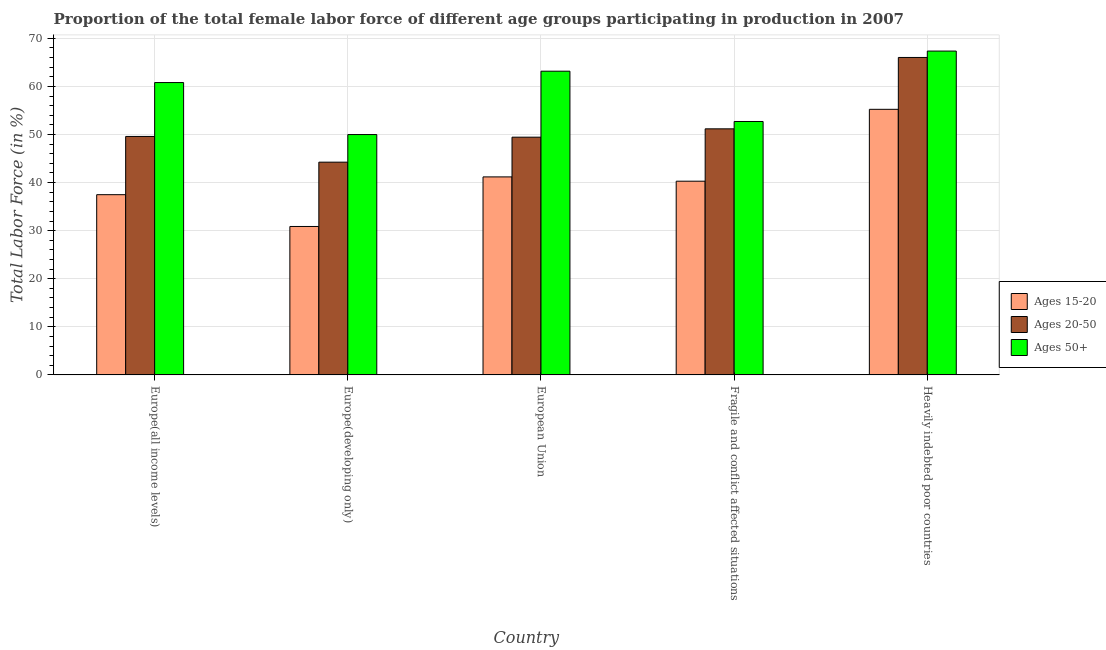How many different coloured bars are there?
Your response must be concise. 3. Are the number of bars on each tick of the X-axis equal?
Your response must be concise. Yes. How many bars are there on the 2nd tick from the left?
Your answer should be compact. 3. What is the label of the 2nd group of bars from the left?
Offer a very short reply. Europe(developing only). In how many cases, is the number of bars for a given country not equal to the number of legend labels?
Your answer should be compact. 0. What is the percentage of female labor force above age 50 in Europe(developing only)?
Make the answer very short. 49.99. Across all countries, what is the maximum percentage of female labor force above age 50?
Offer a terse response. 67.36. Across all countries, what is the minimum percentage of female labor force above age 50?
Make the answer very short. 49.99. In which country was the percentage of female labor force above age 50 maximum?
Your answer should be very brief. Heavily indebted poor countries. In which country was the percentage of female labor force within the age group 15-20 minimum?
Ensure brevity in your answer.  Europe(developing only). What is the total percentage of female labor force within the age group 20-50 in the graph?
Keep it short and to the point. 260.52. What is the difference between the percentage of female labor force above age 50 in Europe(all income levels) and that in Heavily indebted poor countries?
Your answer should be compact. -6.55. What is the difference between the percentage of female labor force within the age group 15-20 in Heavily indebted poor countries and the percentage of female labor force above age 50 in Europe(developing only)?
Your answer should be very brief. 5.25. What is the average percentage of female labor force above age 50 per country?
Provide a short and direct response. 58.81. What is the difference between the percentage of female labor force within the age group 15-20 and percentage of female labor force within the age group 20-50 in Heavily indebted poor countries?
Keep it short and to the point. -10.79. What is the ratio of the percentage of female labor force within the age group 15-20 in Europe(all income levels) to that in European Union?
Provide a succinct answer. 0.91. Is the difference between the percentage of female labor force above age 50 in Europe(developing only) and Heavily indebted poor countries greater than the difference between the percentage of female labor force within the age group 15-20 in Europe(developing only) and Heavily indebted poor countries?
Provide a short and direct response. Yes. What is the difference between the highest and the second highest percentage of female labor force within the age group 20-50?
Make the answer very short. 14.85. What is the difference between the highest and the lowest percentage of female labor force within the age group 20-50?
Provide a succinct answer. 21.78. In how many countries, is the percentage of female labor force above age 50 greater than the average percentage of female labor force above age 50 taken over all countries?
Make the answer very short. 3. Is the sum of the percentage of female labor force within the age group 15-20 in Europe(developing only) and Heavily indebted poor countries greater than the maximum percentage of female labor force above age 50 across all countries?
Provide a short and direct response. Yes. What does the 2nd bar from the left in European Union represents?
Give a very brief answer. Ages 20-50. What does the 1st bar from the right in Europe(all income levels) represents?
Offer a terse response. Ages 50+. Are all the bars in the graph horizontal?
Make the answer very short. No. What is the difference between two consecutive major ticks on the Y-axis?
Provide a short and direct response. 10. Does the graph contain any zero values?
Your response must be concise. No. Where does the legend appear in the graph?
Ensure brevity in your answer.  Center right. How many legend labels are there?
Ensure brevity in your answer.  3. What is the title of the graph?
Provide a short and direct response. Proportion of the total female labor force of different age groups participating in production in 2007. Does "Unemployment benefits" appear as one of the legend labels in the graph?
Provide a succinct answer. No. What is the Total Labor Force (in %) in Ages 15-20 in Europe(all income levels)?
Your answer should be very brief. 37.49. What is the Total Labor Force (in %) in Ages 20-50 in Europe(all income levels)?
Your answer should be compact. 49.6. What is the Total Labor Force (in %) in Ages 50+ in Europe(all income levels)?
Give a very brief answer. 60.81. What is the Total Labor Force (in %) in Ages 15-20 in Europe(developing only)?
Give a very brief answer. 30.88. What is the Total Labor Force (in %) in Ages 20-50 in Europe(developing only)?
Make the answer very short. 44.25. What is the Total Labor Force (in %) of Ages 50+ in Europe(developing only)?
Your response must be concise. 49.99. What is the Total Labor Force (in %) in Ages 15-20 in European Union?
Offer a very short reply. 41.19. What is the Total Labor Force (in %) in Ages 20-50 in European Union?
Keep it short and to the point. 49.45. What is the Total Labor Force (in %) of Ages 50+ in European Union?
Offer a very short reply. 63.17. What is the Total Labor Force (in %) in Ages 15-20 in Fragile and conflict affected situations?
Your answer should be compact. 40.29. What is the Total Labor Force (in %) in Ages 20-50 in Fragile and conflict affected situations?
Your answer should be compact. 51.19. What is the Total Labor Force (in %) in Ages 50+ in Fragile and conflict affected situations?
Ensure brevity in your answer.  52.71. What is the Total Labor Force (in %) of Ages 15-20 in Heavily indebted poor countries?
Ensure brevity in your answer.  55.25. What is the Total Labor Force (in %) of Ages 20-50 in Heavily indebted poor countries?
Offer a very short reply. 66.03. What is the Total Labor Force (in %) in Ages 50+ in Heavily indebted poor countries?
Make the answer very short. 67.36. Across all countries, what is the maximum Total Labor Force (in %) of Ages 15-20?
Make the answer very short. 55.25. Across all countries, what is the maximum Total Labor Force (in %) in Ages 20-50?
Provide a succinct answer. 66.03. Across all countries, what is the maximum Total Labor Force (in %) of Ages 50+?
Make the answer very short. 67.36. Across all countries, what is the minimum Total Labor Force (in %) of Ages 15-20?
Give a very brief answer. 30.88. Across all countries, what is the minimum Total Labor Force (in %) of Ages 20-50?
Give a very brief answer. 44.25. Across all countries, what is the minimum Total Labor Force (in %) in Ages 50+?
Make the answer very short. 49.99. What is the total Total Labor Force (in %) in Ages 15-20 in the graph?
Keep it short and to the point. 205.09. What is the total Total Labor Force (in %) of Ages 20-50 in the graph?
Provide a succinct answer. 260.52. What is the total Total Labor Force (in %) of Ages 50+ in the graph?
Make the answer very short. 294.05. What is the difference between the Total Labor Force (in %) in Ages 15-20 in Europe(all income levels) and that in Europe(developing only)?
Give a very brief answer. 6.61. What is the difference between the Total Labor Force (in %) of Ages 20-50 in Europe(all income levels) and that in Europe(developing only)?
Offer a terse response. 5.35. What is the difference between the Total Labor Force (in %) of Ages 50+ in Europe(all income levels) and that in Europe(developing only)?
Your answer should be very brief. 10.82. What is the difference between the Total Labor Force (in %) of Ages 15-20 in Europe(all income levels) and that in European Union?
Make the answer very short. -3.7. What is the difference between the Total Labor Force (in %) of Ages 20-50 in Europe(all income levels) and that in European Union?
Your response must be concise. 0.15. What is the difference between the Total Labor Force (in %) of Ages 50+ in Europe(all income levels) and that in European Union?
Keep it short and to the point. -2.36. What is the difference between the Total Labor Force (in %) in Ages 15-20 in Europe(all income levels) and that in Fragile and conflict affected situations?
Keep it short and to the point. -2.81. What is the difference between the Total Labor Force (in %) of Ages 20-50 in Europe(all income levels) and that in Fragile and conflict affected situations?
Provide a short and direct response. -1.58. What is the difference between the Total Labor Force (in %) in Ages 50+ in Europe(all income levels) and that in Fragile and conflict affected situations?
Your answer should be compact. 8.1. What is the difference between the Total Labor Force (in %) in Ages 15-20 in Europe(all income levels) and that in Heavily indebted poor countries?
Offer a terse response. -17.76. What is the difference between the Total Labor Force (in %) of Ages 20-50 in Europe(all income levels) and that in Heavily indebted poor countries?
Offer a very short reply. -16.43. What is the difference between the Total Labor Force (in %) in Ages 50+ in Europe(all income levels) and that in Heavily indebted poor countries?
Your response must be concise. -6.55. What is the difference between the Total Labor Force (in %) of Ages 15-20 in Europe(developing only) and that in European Union?
Provide a succinct answer. -10.31. What is the difference between the Total Labor Force (in %) of Ages 20-50 in Europe(developing only) and that in European Union?
Offer a very short reply. -5.2. What is the difference between the Total Labor Force (in %) of Ages 50+ in Europe(developing only) and that in European Union?
Make the answer very short. -13.18. What is the difference between the Total Labor Force (in %) in Ages 15-20 in Europe(developing only) and that in Fragile and conflict affected situations?
Offer a very short reply. -9.42. What is the difference between the Total Labor Force (in %) of Ages 20-50 in Europe(developing only) and that in Fragile and conflict affected situations?
Offer a terse response. -6.93. What is the difference between the Total Labor Force (in %) in Ages 50+ in Europe(developing only) and that in Fragile and conflict affected situations?
Provide a short and direct response. -2.72. What is the difference between the Total Labor Force (in %) in Ages 15-20 in Europe(developing only) and that in Heavily indebted poor countries?
Provide a short and direct response. -24.37. What is the difference between the Total Labor Force (in %) of Ages 20-50 in Europe(developing only) and that in Heavily indebted poor countries?
Your answer should be very brief. -21.78. What is the difference between the Total Labor Force (in %) of Ages 50+ in Europe(developing only) and that in Heavily indebted poor countries?
Your answer should be compact. -17.37. What is the difference between the Total Labor Force (in %) of Ages 15-20 in European Union and that in Fragile and conflict affected situations?
Ensure brevity in your answer.  0.89. What is the difference between the Total Labor Force (in %) in Ages 20-50 in European Union and that in Fragile and conflict affected situations?
Offer a terse response. -1.73. What is the difference between the Total Labor Force (in %) in Ages 50+ in European Union and that in Fragile and conflict affected situations?
Make the answer very short. 10.46. What is the difference between the Total Labor Force (in %) of Ages 15-20 in European Union and that in Heavily indebted poor countries?
Offer a very short reply. -14.06. What is the difference between the Total Labor Force (in %) in Ages 20-50 in European Union and that in Heavily indebted poor countries?
Offer a terse response. -16.58. What is the difference between the Total Labor Force (in %) of Ages 50+ in European Union and that in Heavily indebted poor countries?
Your answer should be compact. -4.19. What is the difference between the Total Labor Force (in %) in Ages 15-20 in Fragile and conflict affected situations and that in Heavily indebted poor countries?
Provide a short and direct response. -14.95. What is the difference between the Total Labor Force (in %) of Ages 20-50 in Fragile and conflict affected situations and that in Heavily indebted poor countries?
Offer a very short reply. -14.85. What is the difference between the Total Labor Force (in %) in Ages 50+ in Fragile and conflict affected situations and that in Heavily indebted poor countries?
Offer a terse response. -14.65. What is the difference between the Total Labor Force (in %) in Ages 15-20 in Europe(all income levels) and the Total Labor Force (in %) in Ages 20-50 in Europe(developing only)?
Give a very brief answer. -6.76. What is the difference between the Total Labor Force (in %) in Ages 15-20 in Europe(all income levels) and the Total Labor Force (in %) in Ages 50+ in Europe(developing only)?
Your answer should be very brief. -12.51. What is the difference between the Total Labor Force (in %) in Ages 20-50 in Europe(all income levels) and the Total Labor Force (in %) in Ages 50+ in Europe(developing only)?
Your answer should be compact. -0.39. What is the difference between the Total Labor Force (in %) in Ages 15-20 in Europe(all income levels) and the Total Labor Force (in %) in Ages 20-50 in European Union?
Make the answer very short. -11.96. What is the difference between the Total Labor Force (in %) in Ages 15-20 in Europe(all income levels) and the Total Labor Force (in %) in Ages 50+ in European Union?
Provide a short and direct response. -25.69. What is the difference between the Total Labor Force (in %) in Ages 20-50 in Europe(all income levels) and the Total Labor Force (in %) in Ages 50+ in European Union?
Keep it short and to the point. -13.57. What is the difference between the Total Labor Force (in %) in Ages 15-20 in Europe(all income levels) and the Total Labor Force (in %) in Ages 20-50 in Fragile and conflict affected situations?
Your answer should be compact. -13.7. What is the difference between the Total Labor Force (in %) of Ages 15-20 in Europe(all income levels) and the Total Labor Force (in %) of Ages 50+ in Fragile and conflict affected situations?
Offer a terse response. -15.23. What is the difference between the Total Labor Force (in %) in Ages 20-50 in Europe(all income levels) and the Total Labor Force (in %) in Ages 50+ in Fragile and conflict affected situations?
Offer a terse response. -3.11. What is the difference between the Total Labor Force (in %) in Ages 15-20 in Europe(all income levels) and the Total Labor Force (in %) in Ages 20-50 in Heavily indebted poor countries?
Provide a short and direct response. -28.54. What is the difference between the Total Labor Force (in %) in Ages 15-20 in Europe(all income levels) and the Total Labor Force (in %) in Ages 50+ in Heavily indebted poor countries?
Ensure brevity in your answer.  -29.87. What is the difference between the Total Labor Force (in %) in Ages 20-50 in Europe(all income levels) and the Total Labor Force (in %) in Ages 50+ in Heavily indebted poor countries?
Offer a very short reply. -17.76. What is the difference between the Total Labor Force (in %) in Ages 15-20 in Europe(developing only) and the Total Labor Force (in %) in Ages 20-50 in European Union?
Offer a very short reply. -18.57. What is the difference between the Total Labor Force (in %) in Ages 15-20 in Europe(developing only) and the Total Labor Force (in %) in Ages 50+ in European Union?
Provide a succinct answer. -32.3. What is the difference between the Total Labor Force (in %) of Ages 20-50 in Europe(developing only) and the Total Labor Force (in %) of Ages 50+ in European Union?
Provide a succinct answer. -18.92. What is the difference between the Total Labor Force (in %) in Ages 15-20 in Europe(developing only) and the Total Labor Force (in %) in Ages 20-50 in Fragile and conflict affected situations?
Keep it short and to the point. -20.31. What is the difference between the Total Labor Force (in %) of Ages 15-20 in Europe(developing only) and the Total Labor Force (in %) of Ages 50+ in Fragile and conflict affected situations?
Ensure brevity in your answer.  -21.84. What is the difference between the Total Labor Force (in %) in Ages 20-50 in Europe(developing only) and the Total Labor Force (in %) in Ages 50+ in Fragile and conflict affected situations?
Provide a succinct answer. -8.46. What is the difference between the Total Labor Force (in %) of Ages 15-20 in Europe(developing only) and the Total Labor Force (in %) of Ages 20-50 in Heavily indebted poor countries?
Ensure brevity in your answer.  -35.15. What is the difference between the Total Labor Force (in %) in Ages 15-20 in Europe(developing only) and the Total Labor Force (in %) in Ages 50+ in Heavily indebted poor countries?
Provide a succinct answer. -36.48. What is the difference between the Total Labor Force (in %) in Ages 20-50 in Europe(developing only) and the Total Labor Force (in %) in Ages 50+ in Heavily indebted poor countries?
Offer a terse response. -23.11. What is the difference between the Total Labor Force (in %) of Ages 15-20 in European Union and the Total Labor Force (in %) of Ages 20-50 in Fragile and conflict affected situations?
Ensure brevity in your answer.  -10. What is the difference between the Total Labor Force (in %) of Ages 15-20 in European Union and the Total Labor Force (in %) of Ages 50+ in Fragile and conflict affected situations?
Your answer should be very brief. -11.53. What is the difference between the Total Labor Force (in %) in Ages 20-50 in European Union and the Total Labor Force (in %) in Ages 50+ in Fragile and conflict affected situations?
Offer a very short reply. -3.26. What is the difference between the Total Labor Force (in %) in Ages 15-20 in European Union and the Total Labor Force (in %) in Ages 20-50 in Heavily indebted poor countries?
Ensure brevity in your answer.  -24.84. What is the difference between the Total Labor Force (in %) in Ages 15-20 in European Union and the Total Labor Force (in %) in Ages 50+ in Heavily indebted poor countries?
Your answer should be very brief. -26.17. What is the difference between the Total Labor Force (in %) of Ages 20-50 in European Union and the Total Labor Force (in %) of Ages 50+ in Heavily indebted poor countries?
Provide a succinct answer. -17.91. What is the difference between the Total Labor Force (in %) of Ages 15-20 in Fragile and conflict affected situations and the Total Labor Force (in %) of Ages 20-50 in Heavily indebted poor countries?
Ensure brevity in your answer.  -25.74. What is the difference between the Total Labor Force (in %) in Ages 15-20 in Fragile and conflict affected situations and the Total Labor Force (in %) in Ages 50+ in Heavily indebted poor countries?
Ensure brevity in your answer.  -27.07. What is the difference between the Total Labor Force (in %) of Ages 20-50 in Fragile and conflict affected situations and the Total Labor Force (in %) of Ages 50+ in Heavily indebted poor countries?
Provide a succinct answer. -16.18. What is the average Total Labor Force (in %) in Ages 15-20 per country?
Ensure brevity in your answer.  41.02. What is the average Total Labor Force (in %) in Ages 20-50 per country?
Give a very brief answer. 52.1. What is the average Total Labor Force (in %) in Ages 50+ per country?
Provide a succinct answer. 58.81. What is the difference between the Total Labor Force (in %) of Ages 15-20 and Total Labor Force (in %) of Ages 20-50 in Europe(all income levels)?
Offer a terse response. -12.11. What is the difference between the Total Labor Force (in %) in Ages 15-20 and Total Labor Force (in %) in Ages 50+ in Europe(all income levels)?
Offer a very short reply. -23.32. What is the difference between the Total Labor Force (in %) of Ages 20-50 and Total Labor Force (in %) of Ages 50+ in Europe(all income levels)?
Offer a very short reply. -11.21. What is the difference between the Total Labor Force (in %) of Ages 15-20 and Total Labor Force (in %) of Ages 20-50 in Europe(developing only)?
Your answer should be very brief. -13.37. What is the difference between the Total Labor Force (in %) of Ages 15-20 and Total Labor Force (in %) of Ages 50+ in Europe(developing only)?
Offer a very short reply. -19.12. What is the difference between the Total Labor Force (in %) of Ages 20-50 and Total Labor Force (in %) of Ages 50+ in Europe(developing only)?
Offer a very short reply. -5.74. What is the difference between the Total Labor Force (in %) of Ages 15-20 and Total Labor Force (in %) of Ages 20-50 in European Union?
Your answer should be very brief. -8.26. What is the difference between the Total Labor Force (in %) in Ages 15-20 and Total Labor Force (in %) in Ages 50+ in European Union?
Provide a short and direct response. -21.99. What is the difference between the Total Labor Force (in %) of Ages 20-50 and Total Labor Force (in %) of Ages 50+ in European Union?
Your answer should be very brief. -13.72. What is the difference between the Total Labor Force (in %) in Ages 15-20 and Total Labor Force (in %) in Ages 20-50 in Fragile and conflict affected situations?
Provide a short and direct response. -10.89. What is the difference between the Total Labor Force (in %) in Ages 15-20 and Total Labor Force (in %) in Ages 50+ in Fragile and conflict affected situations?
Provide a short and direct response. -12.42. What is the difference between the Total Labor Force (in %) in Ages 20-50 and Total Labor Force (in %) in Ages 50+ in Fragile and conflict affected situations?
Your answer should be compact. -1.53. What is the difference between the Total Labor Force (in %) in Ages 15-20 and Total Labor Force (in %) in Ages 20-50 in Heavily indebted poor countries?
Your answer should be very brief. -10.79. What is the difference between the Total Labor Force (in %) in Ages 15-20 and Total Labor Force (in %) in Ages 50+ in Heavily indebted poor countries?
Give a very brief answer. -12.12. What is the difference between the Total Labor Force (in %) of Ages 20-50 and Total Labor Force (in %) of Ages 50+ in Heavily indebted poor countries?
Your response must be concise. -1.33. What is the ratio of the Total Labor Force (in %) in Ages 15-20 in Europe(all income levels) to that in Europe(developing only)?
Provide a short and direct response. 1.21. What is the ratio of the Total Labor Force (in %) of Ages 20-50 in Europe(all income levels) to that in Europe(developing only)?
Keep it short and to the point. 1.12. What is the ratio of the Total Labor Force (in %) of Ages 50+ in Europe(all income levels) to that in Europe(developing only)?
Your response must be concise. 1.22. What is the ratio of the Total Labor Force (in %) in Ages 15-20 in Europe(all income levels) to that in European Union?
Make the answer very short. 0.91. What is the ratio of the Total Labor Force (in %) of Ages 20-50 in Europe(all income levels) to that in European Union?
Ensure brevity in your answer.  1. What is the ratio of the Total Labor Force (in %) in Ages 50+ in Europe(all income levels) to that in European Union?
Ensure brevity in your answer.  0.96. What is the ratio of the Total Labor Force (in %) in Ages 15-20 in Europe(all income levels) to that in Fragile and conflict affected situations?
Offer a terse response. 0.93. What is the ratio of the Total Labor Force (in %) of Ages 20-50 in Europe(all income levels) to that in Fragile and conflict affected situations?
Your response must be concise. 0.97. What is the ratio of the Total Labor Force (in %) of Ages 50+ in Europe(all income levels) to that in Fragile and conflict affected situations?
Offer a very short reply. 1.15. What is the ratio of the Total Labor Force (in %) in Ages 15-20 in Europe(all income levels) to that in Heavily indebted poor countries?
Offer a terse response. 0.68. What is the ratio of the Total Labor Force (in %) in Ages 20-50 in Europe(all income levels) to that in Heavily indebted poor countries?
Provide a short and direct response. 0.75. What is the ratio of the Total Labor Force (in %) of Ages 50+ in Europe(all income levels) to that in Heavily indebted poor countries?
Offer a very short reply. 0.9. What is the ratio of the Total Labor Force (in %) of Ages 15-20 in Europe(developing only) to that in European Union?
Provide a short and direct response. 0.75. What is the ratio of the Total Labor Force (in %) in Ages 20-50 in Europe(developing only) to that in European Union?
Offer a very short reply. 0.89. What is the ratio of the Total Labor Force (in %) in Ages 50+ in Europe(developing only) to that in European Union?
Make the answer very short. 0.79. What is the ratio of the Total Labor Force (in %) of Ages 15-20 in Europe(developing only) to that in Fragile and conflict affected situations?
Your response must be concise. 0.77. What is the ratio of the Total Labor Force (in %) of Ages 20-50 in Europe(developing only) to that in Fragile and conflict affected situations?
Give a very brief answer. 0.86. What is the ratio of the Total Labor Force (in %) in Ages 50+ in Europe(developing only) to that in Fragile and conflict affected situations?
Your answer should be very brief. 0.95. What is the ratio of the Total Labor Force (in %) of Ages 15-20 in Europe(developing only) to that in Heavily indebted poor countries?
Your answer should be very brief. 0.56. What is the ratio of the Total Labor Force (in %) of Ages 20-50 in Europe(developing only) to that in Heavily indebted poor countries?
Make the answer very short. 0.67. What is the ratio of the Total Labor Force (in %) of Ages 50+ in Europe(developing only) to that in Heavily indebted poor countries?
Offer a very short reply. 0.74. What is the ratio of the Total Labor Force (in %) of Ages 15-20 in European Union to that in Fragile and conflict affected situations?
Keep it short and to the point. 1.02. What is the ratio of the Total Labor Force (in %) in Ages 20-50 in European Union to that in Fragile and conflict affected situations?
Keep it short and to the point. 0.97. What is the ratio of the Total Labor Force (in %) in Ages 50+ in European Union to that in Fragile and conflict affected situations?
Ensure brevity in your answer.  1.2. What is the ratio of the Total Labor Force (in %) in Ages 15-20 in European Union to that in Heavily indebted poor countries?
Offer a very short reply. 0.75. What is the ratio of the Total Labor Force (in %) of Ages 20-50 in European Union to that in Heavily indebted poor countries?
Offer a very short reply. 0.75. What is the ratio of the Total Labor Force (in %) of Ages 50+ in European Union to that in Heavily indebted poor countries?
Offer a terse response. 0.94. What is the ratio of the Total Labor Force (in %) of Ages 15-20 in Fragile and conflict affected situations to that in Heavily indebted poor countries?
Keep it short and to the point. 0.73. What is the ratio of the Total Labor Force (in %) of Ages 20-50 in Fragile and conflict affected situations to that in Heavily indebted poor countries?
Your response must be concise. 0.78. What is the ratio of the Total Labor Force (in %) of Ages 50+ in Fragile and conflict affected situations to that in Heavily indebted poor countries?
Give a very brief answer. 0.78. What is the difference between the highest and the second highest Total Labor Force (in %) in Ages 15-20?
Ensure brevity in your answer.  14.06. What is the difference between the highest and the second highest Total Labor Force (in %) of Ages 20-50?
Ensure brevity in your answer.  14.85. What is the difference between the highest and the second highest Total Labor Force (in %) of Ages 50+?
Offer a terse response. 4.19. What is the difference between the highest and the lowest Total Labor Force (in %) in Ages 15-20?
Your answer should be very brief. 24.37. What is the difference between the highest and the lowest Total Labor Force (in %) in Ages 20-50?
Your response must be concise. 21.78. What is the difference between the highest and the lowest Total Labor Force (in %) of Ages 50+?
Provide a succinct answer. 17.37. 